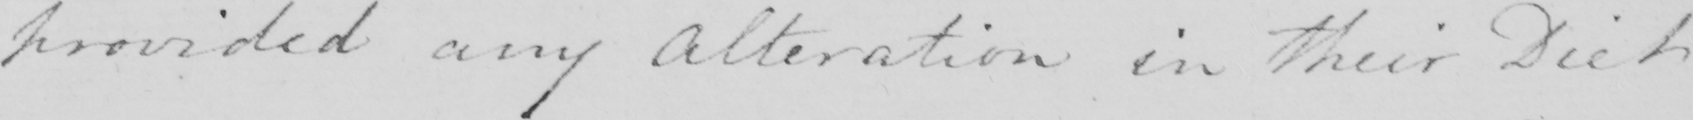Please transcribe the handwritten text in this image. provided any Alteration in their Diet 